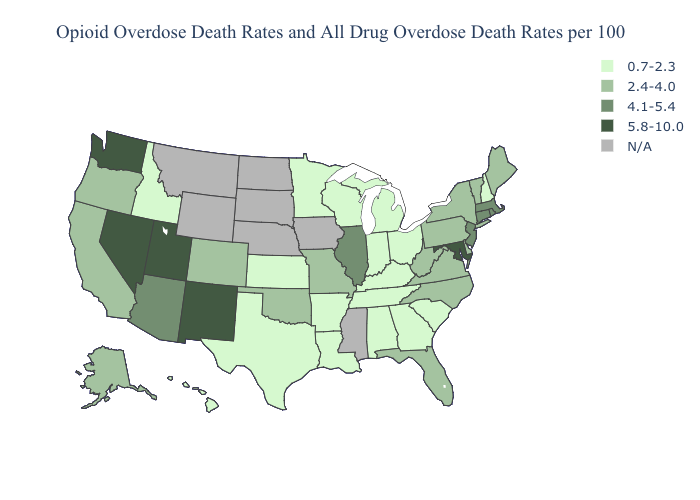What is the value of Louisiana?
Keep it brief. 0.7-2.3. Does the first symbol in the legend represent the smallest category?
Short answer required. Yes. Among the states that border Missouri , does Oklahoma have the highest value?
Keep it brief. No. What is the highest value in the USA?
Short answer required. 5.8-10.0. What is the highest value in states that border Maryland?
Give a very brief answer. 2.4-4.0. Is the legend a continuous bar?
Answer briefly. No. Does Kentucky have the lowest value in the USA?
Keep it brief. Yes. What is the highest value in the USA?
Concise answer only. 5.8-10.0. What is the highest value in the USA?
Short answer required. 5.8-10.0. Name the states that have a value in the range 2.4-4.0?
Keep it brief. Alaska, California, Colorado, Delaware, Florida, Maine, Missouri, New York, North Carolina, Oklahoma, Oregon, Pennsylvania, Vermont, Virginia, West Virginia. What is the value of Nevada?
Concise answer only. 5.8-10.0. Name the states that have a value in the range 5.8-10.0?
Quick response, please. Maryland, Nevada, New Mexico, Utah, Washington. What is the value of Hawaii?
Keep it brief. 0.7-2.3. 